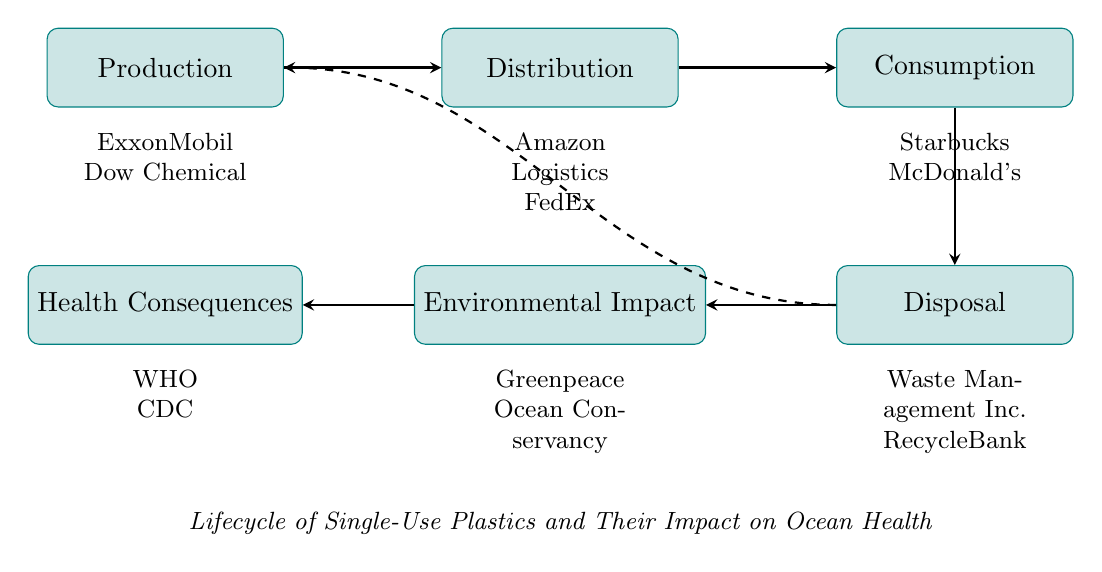What is the first node in the diagram? The first node, which is the starting point of the flowchart, is "Production."
Answer: Production How many nodes are represented in the diagram? The diagram contains a total of six nodes. These include Production, Distribution, Consumption, Disposal, Environmental Impact, and Health Consequences.
Answer: Six What is the last node in the flow? The last node in the flow of the diagram is "Health Consequences."
Answer: Health Consequences Which organizations are associated with the "Environmental Impact" node? The organizations listed under the "Environmental Impact" node are "Greenpeace" and "Ocean Conservancy."
Answer: Greenpeace, Ocean Conservancy What is the relationship between "Disposal" and "Environmental Impact"? The diagram shows a direct flow from "Disposal" to "Environmental Impact," indicating that disposal methods affect the environment.
Answer: Direct flow What happens to single-use plastics after "Disposal" according to the flowchart? After "Disposal," single-use plastics lead to "Environmental Impact," which specifies the adverse effects on ocean health.
Answer: Environmental Impact Which node has organizations related to public health? The "Health Consequences" node includes organizations related to public health, specifically "World Health Organization" and "Center for Disease Control and Prevention."
Answer: Health Consequences What is the overall theme of the flowchart? The overall theme depicted in the flowchart is the lifecycle of single-use plastics and their impact on ocean health.
Answer: Lifecycle of Single-Use Plastics and Their Impact on Ocean Health What is the direction of flow from "Production" to "Consumption"? The flowchart indicates a sequential flow from "Production" through "Distribution" to "Consumption," signifying the journey of plastics in the market.
Answer: Sequential flow 